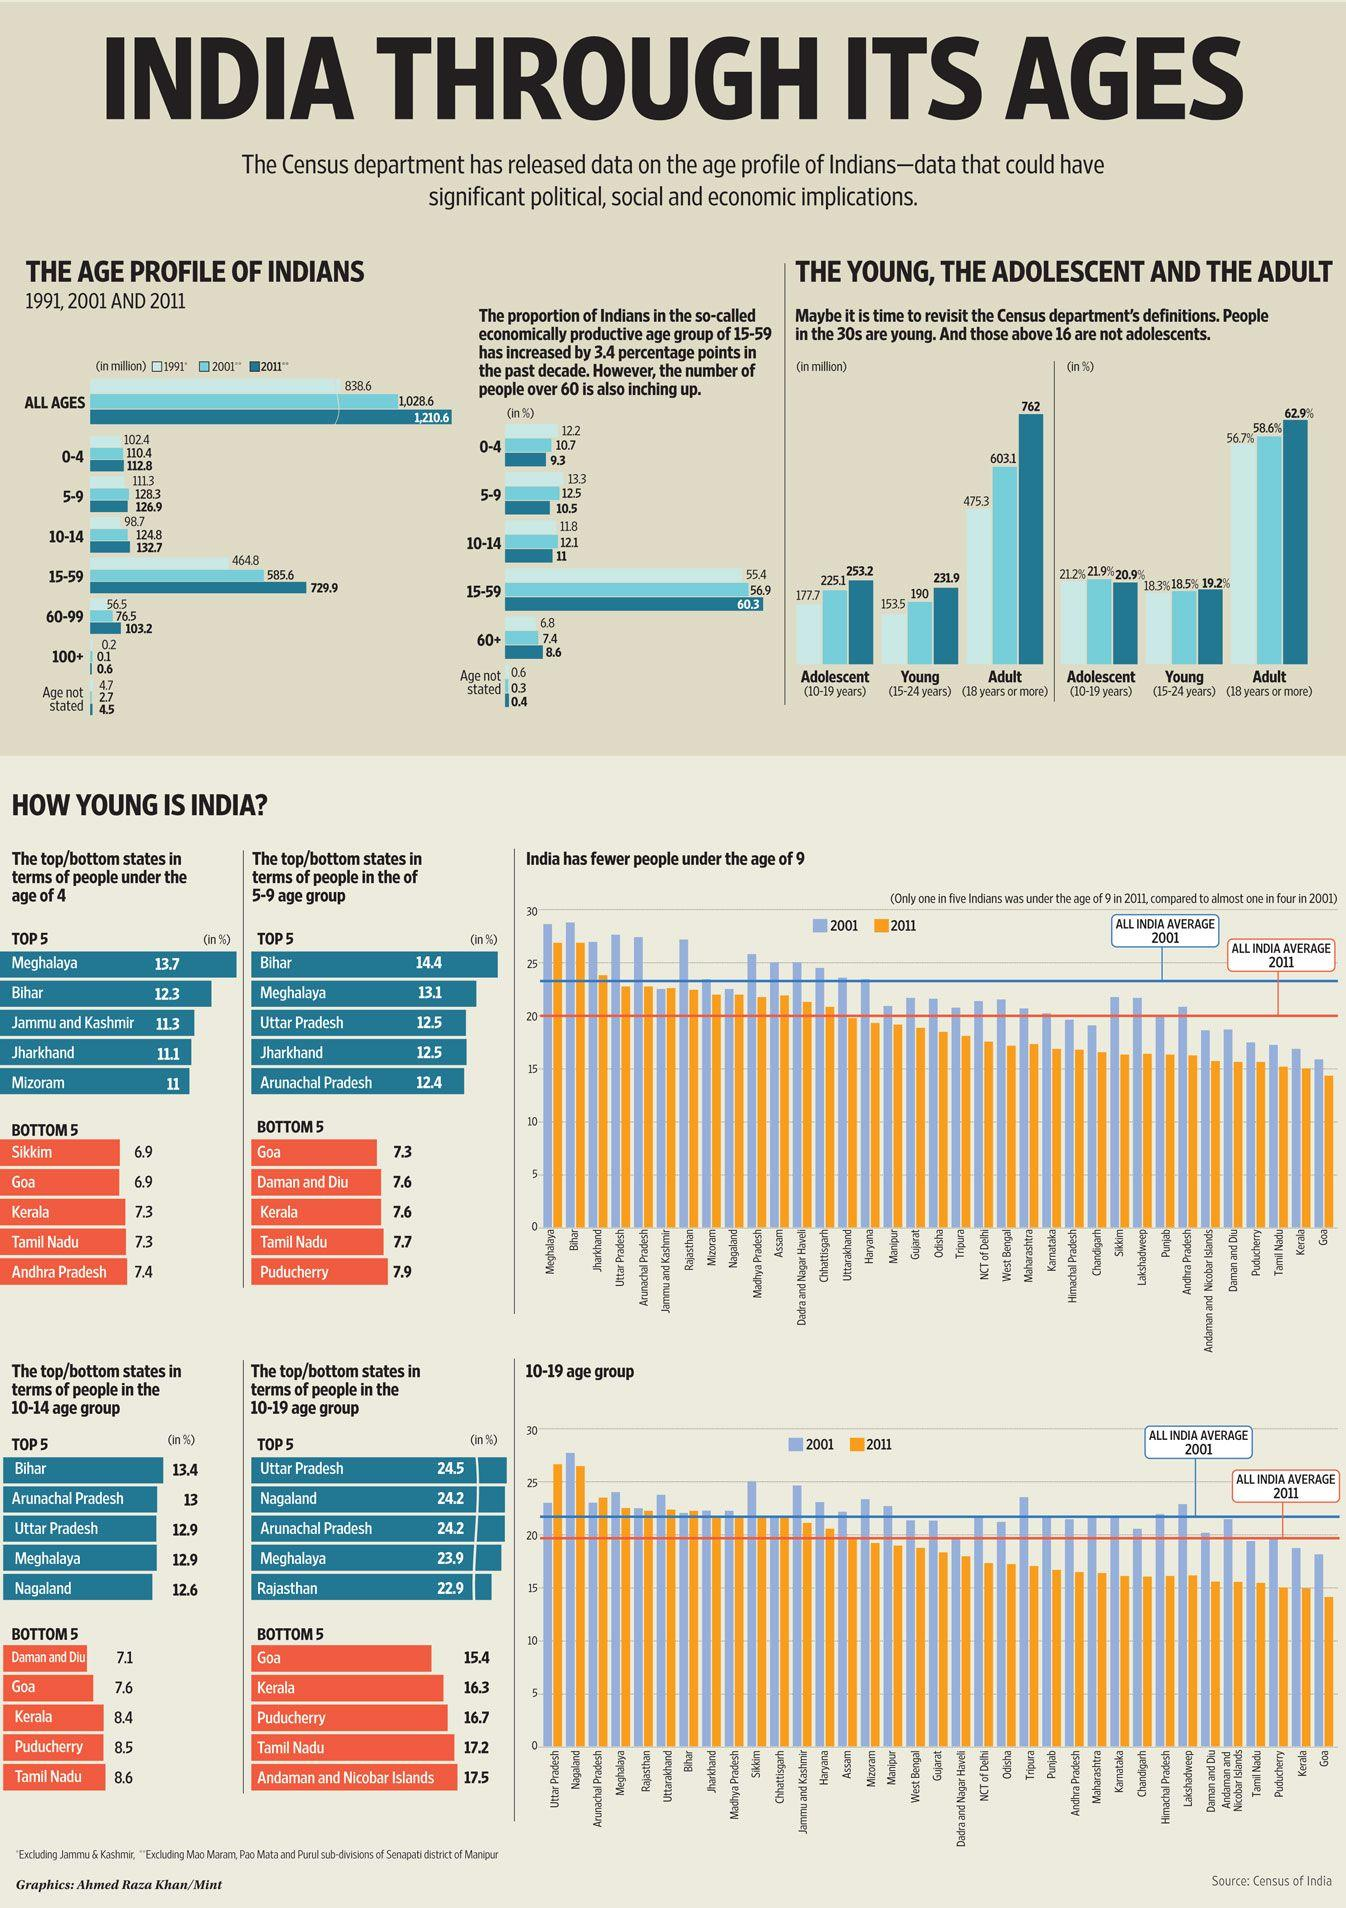Mention a couple of crucial points in this snapshot. Uttar Pradesh has the highest percentage of people in the age group of 10-19 years among all Indian states. In 2001, approximately 56.9% of the Indian population fell within the age group of 15-59 years. In 2011, an estimated 132.7 million people in India were between the ages of 10 and 14, according to a statistical report. According to statistics, approximately 8.4% of the population in Kerala is within the age range of 10 to 14 years. In 2001, there were approximately 0.1 million people aged 100 or older in India. 